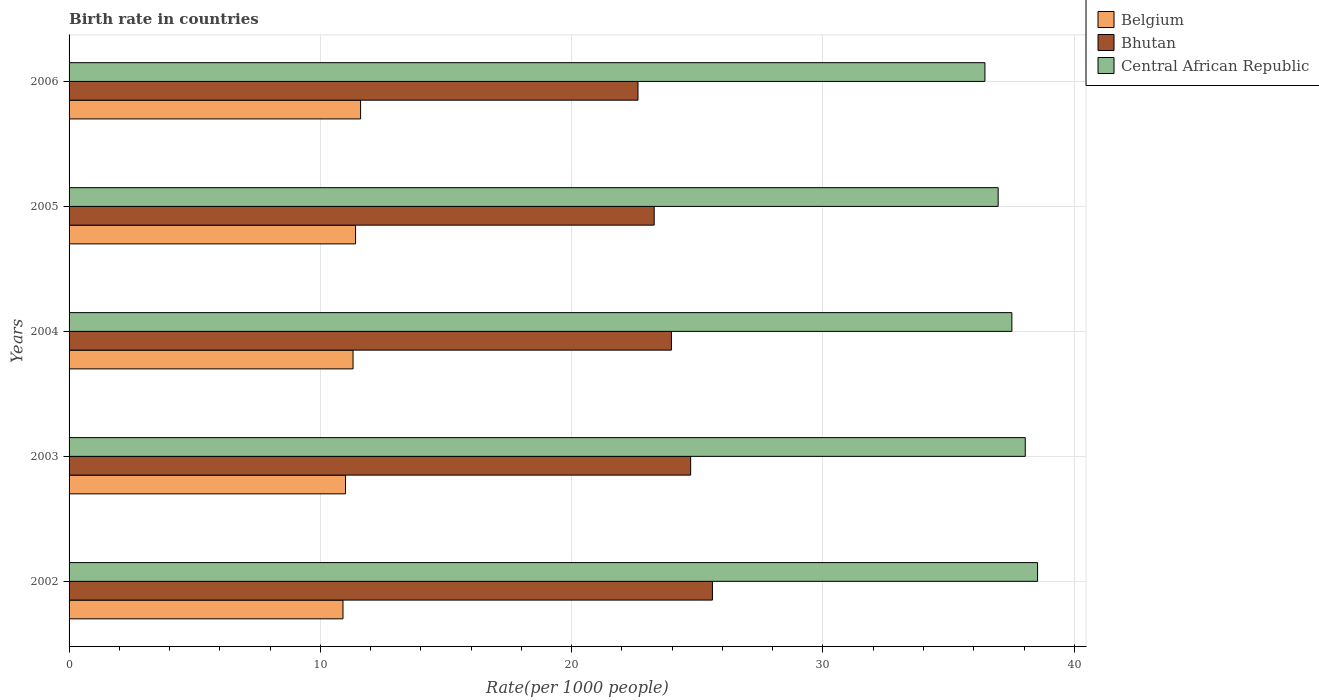How many different coloured bars are there?
Provide a succinct answer. 3. How many bars are there on the 2nd tick from the bottom?
Offer a terse response. 3. In how many cases, is the number of bars for a given year not equal to the number of legend labels?
Provide a succinct answer. 0. Across all years, what is the maximum birth rate in Central African Republic?
Give a very brief answer. 38.54. Across all years, what is the minimum birth rate in Bhutan?
Offer a terse response. 22.64. In which year was the birth rate in Belgium maximum?
Make the answer very short. 2006. What is the total birth rate in Central African Republic in the graph?
Your answer should be compact. 187.52. What is the difference between the birth rate in Belgium in 2005 and that in 2006?
Your answer should be very brief. -0.2. What is the difference between the birth rate in Belgium in 2004 and the birth rate in Central African Republic in 2005?
Provide a succinct answer. -25.67. What is the average birth rate in Central African Republic per year?
Ensure brevity in your answer.  37.5. In the year 2005, what is the difference between the birth rate in Belgium and birth rate in Central African Republic?
Your answer should be compact. -25.57. In how many years, is the birth rate in Bhutan greater than 34 ?
Your response must be concise. 0. What is the ratio of the birth rate in Belgium in 2005 to that in 2006?
Keep it short and to the point. 0.98. Is the birth rate in Belgium in 2002 less than that in 2004?
Offer a terse response. Yes. Is the difference between the birth rate in Belgium in 2004 and 2006 greater than the difference between the birth rate in Central African Republic in 2004 and 2006?
Give a very brief answer. No. What is the difference between the highest and the second highest birth rate in Bhutan?
Offer a very short reply. 0.87. What is the difference between the highest and the lowest birth rate in Central African Republic?
Keep it short and to the point. 2.09. Is the sum of the birth rate in Belgium in 2002 and 2004 greater than the maximum birth rate in Bhutan across all years?
Offer a very short reply. No. What does the 1st bar from the top in 2003 represents?
Give a very brief answer. Central African Republic. What does the 1st bar from the bottom in 2002 represents?
Offer a terse response. Belgium. How many years are there in the graph?
Your answer should be compact. 5. What is the difference between two consecutive major ticks on the X-axis?
Your response must be concise. 10. Are the values on the major ticks of X-axis written in scientific E-notation?
Your answer should be compact. No. Does the graph contain any zero values?
Keep it short and to the point. No. Where does the legend appear in the graph?
Provide a succinct answer. Top right. What is the title of the graph?
Your answer should be compact. Birth rate in countries. Does "French Polynesia" appear as one of the legend labels in the graph?
Offer a terse response. No. What is the label or title of the X-axis?
Keep it short and to the point. Rate(per 1000 people). What is the Rate(per 1000 people) of Bhutan in 2002?
Offer a terse response. 25.6. What is the Rate(per 1000 people) of Central African Republic in 2002?
Offer a very short reply. 38.54. What is the Rate(per 1000 people) in Belgium in 2003?
Ensure brevity in your answer.  11. What is the Rate(per 1000 people) of Bhutan in 2003?
Your answer should be compact. 24.73. What is the Rate(per 1000 people) in Central African Republic in 2003?
Offer a terse response. 38.05. What is the Rate(per 1000 people) in Bhutan in 2004?
Give a very brief answer. 23.97. What is the Rate(per 1000 people) of Central African Republic in 2004?
Give a very brief answer. 37.52. What is the Rate(per 1000 people) of Bhutan in 2005?
Provide a short and direct response. 23.28. What is the Rate(per 1000 people) of Central African Republic in 2005?
Keep it short and to the point. 36.97. What is the Rate(per 1000 people) of Belgium in 2006?
Your response must be concise. 11.6. What is the Rate(per 1000 people) of Bhutan in 2006?
Keep it short and to the point. 22.64. What is the Rate(per 1000 people) in Central African Republic in 2006?
Offer a very short reply. 36.44. Across all years, what is the maximum Rate(per 1000 people) in Bhutan?
Give a very brief answer. 25.6. Across all years, what is the maximum Rate(per 1000 people) of Central African Republic?
Provide a short and direct response. 38.54. Across all years, what is the minimum Rate(per 1000 people) of Belgium?
Give a very brief answer. 10.9. Across all years, what is the minimum Rate(per 1000 people) of Bhutan?
Provide a succinct answer. 22.64. Across all years, what is the minimum Rate(per 1000 people) of Central African Republic?
Give a very brief answer. 36.44. What is the total Rate(per 1000 people) of Belgium in the graph?
Your answer should be very brief. 56.2. What is the total Rate(per 1000 people) of Bhutan in the graph?
Offer a terse response. 120.22. What is the total Rate(per 1000 people) in Central African Republic in the graph?
Your answer should be very brief. 187.52. What is the difference between the Rate(per 1000 people) of Belgium in 2002 and that in 2003?
Ensure brevity in your answer.  -0.1. What is the difference between the Rate(per 1000 people) in Bhutan in 2002 and that in 2003?
Your answer should be compact. 0.87. What is the difference between the Rate(per 1000 people) in Central African Republic in 2002 and that in 2003?
Offer a terse response. 0.49. What is the difference between the Rate(per 1000 people) in Belgium in 2002 and that in 2004?
Give a very brief answer. -0.4. What is the difference between the Rate(per 1000 people) of Bhutan in 2002 and that in 2004?
Your response must be concise. 1.63. What is the difference between the Rate(per 1000 people) in Bhutan in 2002 and that in 2005?
Give a very brief answer. 2.32. What is the difference between the Rate(per 1000 people) in Central African Republic in 2002 and that in 2005?
Make the answer very short. 1.57. What is the difference between the Rate(per 1000 people) in Belgium in 2002 and that in 2006?
Ensure brevity in your answer.  -0.7. What is the difference between the Rate(per 1000 people) in Bhutan in 2002 and that in 2006?
Your answer should be very brief. 2.96. What is the difference between the Rate(per 1000 people) of Central African Republic in 2002 and that in 2006?
Your response must be concise. 2.1. What is the difference between the Rate(per 1000 people) in Belgium in 2003 and that in 2004?
Provide a short and direct response. -0.3. What is the difference between the Rate(per 1000 people) of Bhutan in 2003 and that in 2004?
Keep it short and to the point. 0.77. What is the difference between the Rate(per 1000 people) of Central African Republic in 2003 and that in 2004?
Your response must be concise. 0.53. What is the difference between the Rate(per 1000 people) of Bhutan in 2003 and that in 2005?
Make the answer very short. 1.45. What is the difference between the Rate(per 1000 people) in Central African Republic in 2003 and that in 2005?
Offer a terse response. 1.08. What is the difference between the Rate(per 1000 people) in Bhutan in 2003 and that in 2006?
Your answer should be compact. 2.1. What is the difference between the Rate(per 1000 people) of Central African Republic in 2003 and that in 2006?
Make the answer very short. 1.6. What is the difference between the Rate(per 1000 people) in Bhutan in 2004 and that in 2005?
Make the answer very short. 0.69. What is the difference between the Rate(per 1000 people) in Central African Republic in 2004 and that in 2005?
Offer a terse response. 0.55. What is the difference between the Rate(per 1000 people) of Belgium in 2004 and that in 2006?
Keep it short and to the point. -0.3. What is the difference between the Rate(per 1000 people) in Bhutan in 2004 and that in 2006?
Your answer should be compact. 1.33. What is the difference between the Rate(per 1000 people) in Central African Republic in 2004 and that in 2006?
Provide a succinct answer. 1.07. What is the difference between the Rate(per 1000 people) in Bhutan in 2005 and that in 2006?
Keep it short and to the point. 0.65. What is the difference between the Rate(per 1000 people) in Central African Republic in 2005 and that in 2006?
Give a very brief answer. 0.53. What is the difference between the Rate(per 1000 people) of Belgium in 2002 and the Rate(per 1000 people) of Bhutan in 2003?
Provide a short and direct response. -13.83. What is the difference between the Rate(per 1000 people) in Belgium in 2002 and the Rate(per 1000 people) in Central African Republic in 2003?
Offer a very short reply. -27.15. What is the difference between the Rate(per 1000 people) in Bhutan in 2002 and the Rate(per 1000 people) in Central African Republic in 2003?
Ensure brevity in your answer.  -12.45. What is the difference between the Rate(per 1000 people) in Belgium in 2002 and the Rate(per 1000 people) in Bhutan in 2004?
Keep it short and to the point. -13.07. What is the difference between the Rate(per 1000 people) of Belgium in 2002 and the Rate(per 1000 people) of Central African Republic in 2004?
Provide a short and direct response. -26.62. What is the difference between the Rate(per 1000 people) of Bhutan in 2002 and the Rate(per 1000 people) of Central African Republic in 2004?
Give a very brief answer. -11.91. What is the difference between the Rate(per 1000 people) in Belgium in 2002 and the Rate(per 1000 people) in Bhutan in 2005?
Provide a short and direct response. -12.38. What is the difference between the Rate(per 1000 people) of Belgium in 2002 and the Rate(per 1000 people) of Central African Republic in 2005?
Give a very brief answer. -26.07. What is the difference between the Rate(per 1000 people) of Bhutan in 2002 and the Rate(per 1000 people) of Central African Republic in 2005?
Provide a short and direct response. -11.37. What is the difference between the Rate(per 1000 people) in Belgium in 2002 and the Rate(per 1000 people) in Bhutan in 2006?
Offer a terse response. -11.74. What is the difference between the Rate(per 1000 people) in Belgium in 2002 and the Rate(per 1000 people) in Central African Republic in 2006?
Offer a very short reply. -25.54. What is the difference between the Rate(per 1000 people) of Bhutan in 2002 and the Rate(per 1000 people) of Central African Republic in 2006?
Make the answer very short. -10.84. What is the difference between the Rate(per 1000 people) in Belgium in 2003 and the Rate(per 1000 people) in Bhutan in 2004?
Offer a terse response. -12.97. What is the difference between the Rate(per 1000 people) in Belgium in 2003 and the Rate(per 1000 people) in Central African Republic in 2004?
Offer a terse response. -26.52. What is the difference between the Rate(per 1000 people) in Bhutan in 2003 and the Rate(per 1000 people) in Central African Republic in 2004?
Your answer should be compact. -12.78. What is the difference between the Rate(per 1000 people) of Belgium in 2003 and the Rate(per 1000 people) of Bhutan in 2005?
Provide a succinct answer. -12.28. What is the difference between the Rate(per 1000 people) in Belgium in 2003 and the Rate(per 1000 people) in Central African Republic in 2005?
Offer a terse response. -25.97. What is the difference between the Rate(per 1000 people) of Bhutan in 2003 and the Rate(per 1000 people) of Central African Republic in 2005?
Offer a terse response. -12.24. What is the difference between the Rate(per 1000 people) of Belgium in 2003 and the Rate(per 1000 people) of Bhutan in 2006?
Your response must be concise. -11.64. What is the difference between the Rate(per 1000 people) in Belgium in 2003 and the Rate(per 1000 people) in Central African Republic in 2006?
Provide a short and direct response. -25.44. What is the difference between the Rate(per 1000 people) of Bhutan in 2003 and the Rate(per 1000 people) of Central African Republic in 2006?
Your answer should be compact. -11.71. What is the difference between the Rate(per 1000 people) in Belgium in 2004 and the Rate(per 1000 people) in Bhutan in 2005?
Offer a very short reply. -11.98. What is the difference between the Rate(per 1000 people) in Belgium in 2004 and the Rate(per 1000 people) in Central African Republic in 2005?
Keep it short and to the point. -25.67. What is the difference between the Rate(per 1000 people) in Bhutan in 2004 and the Rate(per 1000 people) in Central African Republic in 2005?
Provide a short and direct response. -13. What is the difference between the Rate(per 1000 people) of Belgium in 2004 and the Rate(per 1000 people) of Bhutan in 2006?
Your answer should be very brief. -11.34. What is the difference between the Rate(per 1000 people) of Belgium in 2004 and the Rate(per 1000 people) of Central African Republic in 2006?
Your response must be concise. -25.14. What is the difference between the Rate(per 1000 people) of Bhutan in 2004 and the Rate(per 1000 people) of Central African Republic in 2006?
Provide a succinct answer. -12.47. What is the difference between the Rate(per 1000 people) of Belgium in 2005 and the Rate(per 1000 people) of Bhutan in 2006?
Give a very brief answer. -11.24. What is the difference between the Rate(per 1000 people) of Belgium in 2005 and the Rate(per 1000 people) of Central African Republic in 2006?
Provide a short and direct response. -25.04. What is the difference between the Rate(per 1000 people) in Bhutan in 2005 and the Rate(per 1000 people) in Central African Republic in 2006?
Provide a succinct answer. -13.16. What is the average Rate(per 1000 people) in Belgium per year?
Provide a succinct answer. 11.24. What is the average Rate(per 1000 people) of Bhutan per year?
Keep it short and to the point. 24.05. What is the average Rate(per 1000 people) of Central African Republic per year?
Provide a short and direct response. 37.5. In the year 2002, what is the difference between the Rate(per 1000 people) in Belgium and Rate(per 1000 people) in Bhutan?
Provide a short and direct response. -14.7. In the year 2002, what is the difference between the Rate(per 1000 people) of Belgium and Rate(per 1000 people) of Central African Republic?
Your answer should be compact. -27.64. In the year 2002, what is the difference between the Rate(per 1000 people) in Bhutan and Rate(per 1000 people) in Central African Republic?
Provide a succinct answer. -12.94. In the year 2003, what is the difference between the Rate(per 1000 people) in Belgium and Rate(per 1000 people) in Bhutan?
Your answer should be compact. -13.73. In the year 2003, what is the difference between the Rate(per 1000 people) in Belgium and Rate(per 1000 people) in Central African Republic?
Keep it short and to the point. -27.05. In the year 2003, what is the difference between the Rate(per 1000 people) of Bhutan and Rate(per 1000 people) of Central African Republic?
Your answer should be very brief. -13.31. In the year 2004, what is the difference between the Rate(per 1000 people) in Belgium and Rate(per 1000 people) in Bhutan?
Your answer should be compact. -12.67. In the year 2004, what is the difference between the Rate(per 1000 people) in Belgium and Rate(per 1000 people) in Central African Republic?
Make the answer very short. -26.22. In the year 2004, what is the difference between the Rate(per 1000 people) of Bhutan and Rate(per 1000 people) of Central African Republic?
Provide a short and direct response. -13.55. In the year 2005, what is the difference between the Rate(per 1000 people) of Belgium and Rate(per 1000 people) of Bhutan?
Make the answer very short. -11.88. In the year 2005, what is the difference between the Rate(per 1000 people) of Belgium and Rate(per 1000 people) of Central African Republic?
Offer a very short reply. -25.57. In the year 2005, what is the difference between the Rate(per 1000 people) in Bhutan and Rate(per 1000 people) in Central African Republic?
Offer a very short reply. -13.69. In the year 2006, what is the difference between the Rate(per 1000 people) of Belgium and Rate(per 1000 people) of Bhutan?
Keep it short and to the point. -11.04. In the year 2006, what is the difference between the Rate(per 1000 people) of Belgium and Rate(per 1000 people) of Central African Republic?
Offer a terse response. -24.84. In the year 2006, what is the difference between the Rate(per 1000 people) of Bhutan and Rate(per 1000 people) of Central African Republic?
Your answer should be very brief. -13.81. What is the ratio of the Rate(per 1000 people) of Belgium in 2002 to that in 2003?
Offer a terse response. 0.99. What is the ratio of the Rate(per 1000 people) in Bhutan in 2002 to that in 2003?
Make the answer very short. 1.04. What is the ratio of the Rate(per 1000 people) of Central African Republic in 2002 to that in 2003?
Provide a short and direct response. 1.01. What is the ratio of the Rate(per 1000 people) in Belgium in 2002 to that in 2004?
Your response must be concise. 0.96. What is the ratio of the Rate(per 1000 people) in Bhutan in 2002 to that in 2004?
Your response must be concise. 1.07. What is the ratio of the Rate(per 1000 people) in Central African Republic in 2002 to that in 2004?
Your answer should be very brief. 1.03. What is the ratio of the Rate(per 1000 people) of Belgium in 2002 to that in 2005?
Give a very brief answer. 0.96. What is the ratio of the Rate(per 1000 people) of Bhutan in 2002 to that in 2005?
Give a very brief answer. 1.1. What is the ratio of the Rate(per 1000 people) of Central African Republic in 2002 to that in 2005?
Keep it short and to the point. 1.04. What is the ratio of the Rate(per 1000 people) of Belgium in 2002 to that in 2006?
Your response must be concise. 0.94. What is the ratio of the Rate(per 1000 people) of Bhutan in 2002 to that in 2006?
Make the answer very short. 1.13. What is the ratio of the Rate(per 1000 people) in Central African Republic in 2002 to that in 2006?
Offer a very short reply. 1.06. What is the ratio of the Rate(per 1000 people) in Belgium in 2003 to that in 2004?
Offer a terse response. 0.97. What is the ratio of the Rate(per 1000 people) in Bhutan in 2003 to that in 2004?
Give a very brief answer. 1.03. What is the ratio of the Rate(per 1000 people) of Central African Republic in 2003 to that in 2004?
Ensure brevity in your answer.  1.01. What is the ratio of the Rate(per 1000 people) in Belgium in 2003 to that in 2005?
Offer a terse response. 0.96. What is the ratio of the Rate(per 1000 people) of Bhutan in 2003 to that in 2005?
Give a very brief answer. 1.06. What is the ratio of the Rate(per 1000 people) in Central African Republic in 2003 to that in 2005?
Provide a succinct answer. 1.03. What is the ratio of the Rate(per 1000 people) in Belgium in 2003 to that in 2006?
Your answer should be compact. 0.95. What is the ratio of the Rate(per 1000 people) in Bhutan in 2003 to that in 2006?
Your answer should be very brief. 1.09. What is the ratio of the Rate(per 1000 people) of Central African Republic in 2003 to that in 2006?
Your response must be concise. 1.04. What is the ratio of the Rate(per 1000 people) of Bhutan in 2004 to that in 2005?
Your answer should be compact. 1.03. What is the ratio of the Rate(per 1000 people) in Central African Republic in 2004 to that in 2005?
Offer a terse response. 1.01. What is the ratio of the Rate(per 1000 people) in Belgium in 2004 to that in 2006?
Give a very brief answer. 0.97. What is the ratio of the Rate(per 1000 people) of Bhutan in 2004 to that in 2006?
Your response must be concise. 1.06. What is the ratio of the Rate(per 1000 people) in Central African Republic in 2004 to that in 2006?
Offer a terse response. 1.03. What is the ratio of the Rate(per 1000 people) of Belgium in 2005 to that in 2006?
Keep it short and to the point. 0.98. What is the ratio of the Rate(per 1000 people) of Bhutan in 2005 to that in 2006?
Your answer should be very brief. 1.03. What is the ratio of the Rate(per 1000 people) in Central African Republic in 2005 to that in 2006?
Your answer should be compact. 1.01. What is the difference between the highest and the second highest Rate(per 1000 people) in Belgium?
Offer a very short reply. 0.2. What is the difference between the highest and the second highest Rate(per 1000 people) in Bhutan?
Keep it short and to the point. 0.87. What is the difference between the highest and the second highest Rate(per 1000 people) of Central African Republic?
Ensure brevity in your answer.  0.49. What is the difference between the highest and the lowest Rate(per 1000 people) in Bhutan?
Ensure brevity in your answer.  2.96. What is the difference between the highest and the lowest Rate(per 1000 people) in Central African Republic?
Offer a very short reply. 2.1. 